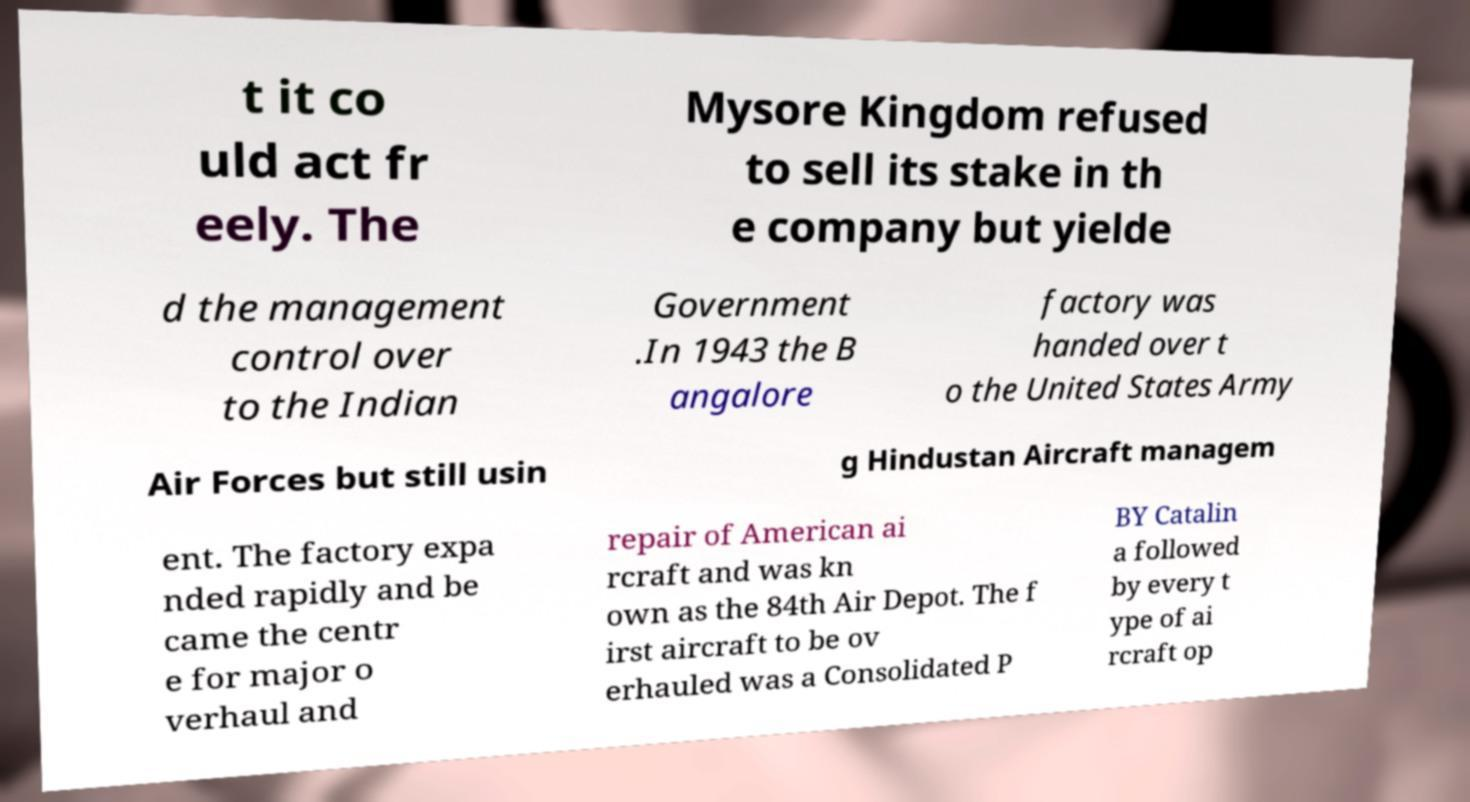Please read and relay the text visible in this image. What does it say? t it co uld act fr eely. The Mysore Kingdom refused to sell its stake in th e company but yielde d the management control over to the Indian Government .In 1943 the B angalore factory was handed over t o the United States Army Air Forces but still usin g Hindustan Aircraft managem ent. The factory expa nded rapidly and be came the centr e for major o verhaul and repair of American ai rcraft and was kn own as the 84th Air Depot. The f irst aircraft to be ov erhauled was a Consolidated P BY Catalin a followed by every t ype of ai rcraft op 